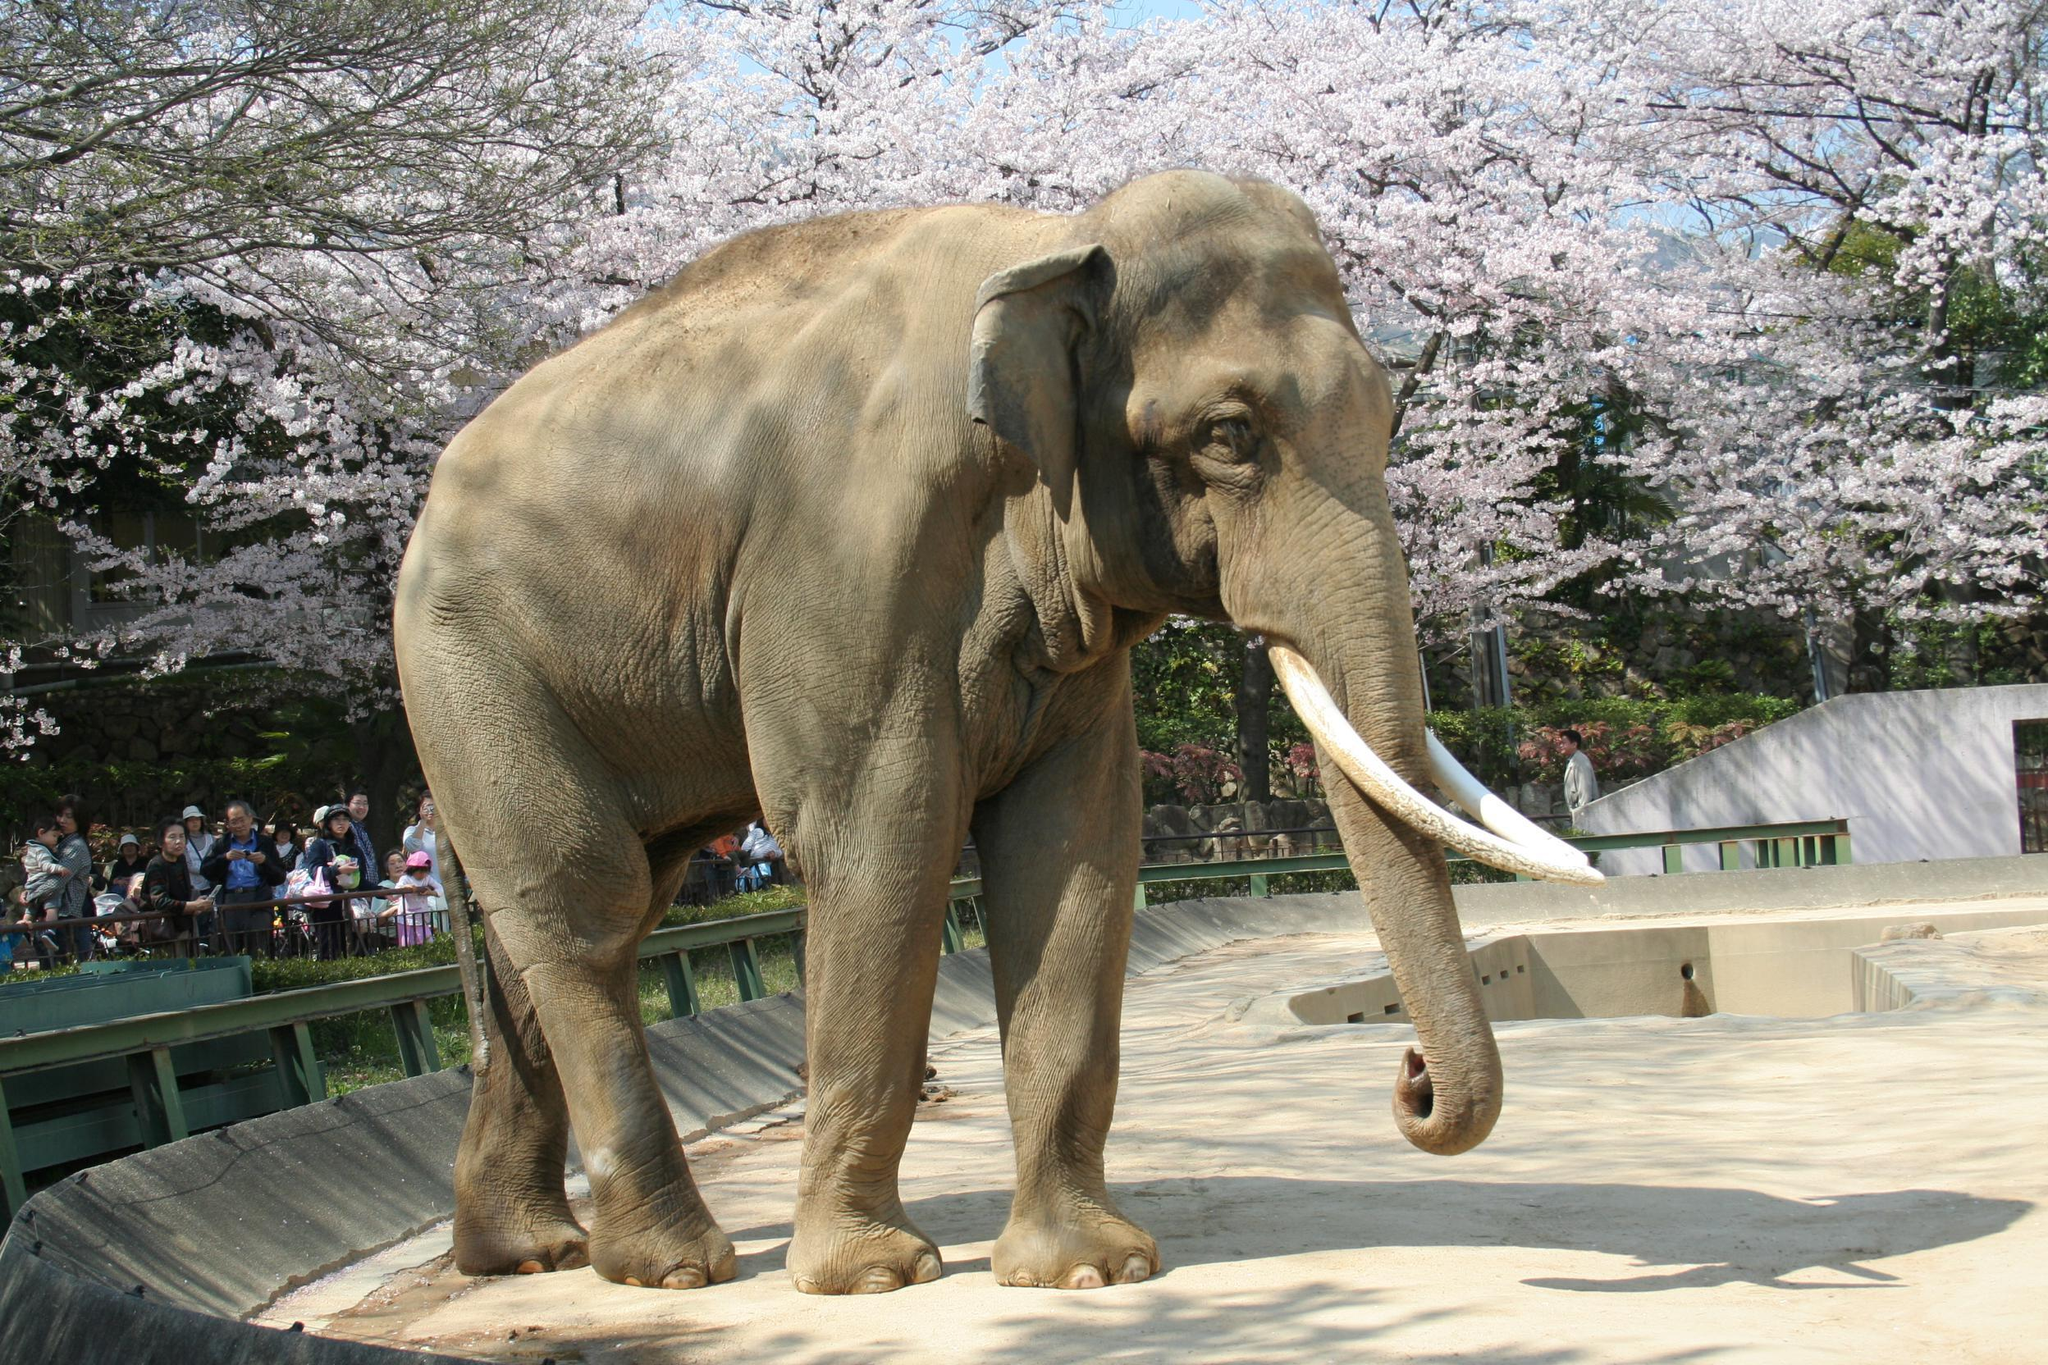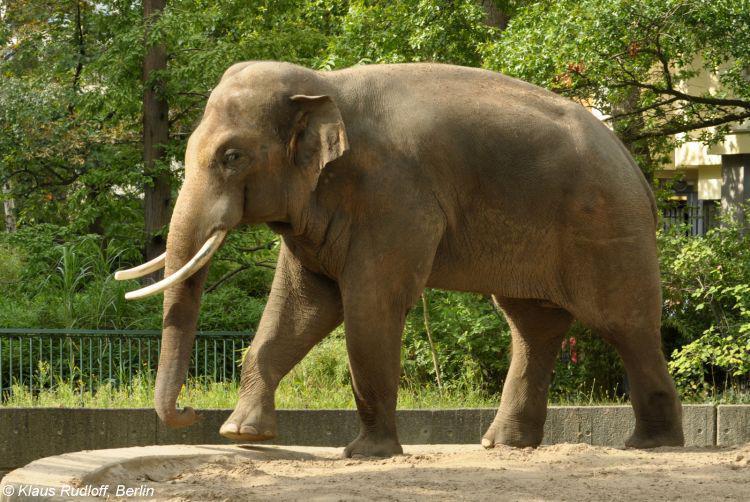The first image is the image on the left, the second image is the image on the right. For the images shown, is this caption "A tusked elephant stands on a concrete area in the image on the right." true? Answer yes or no. Yes. 